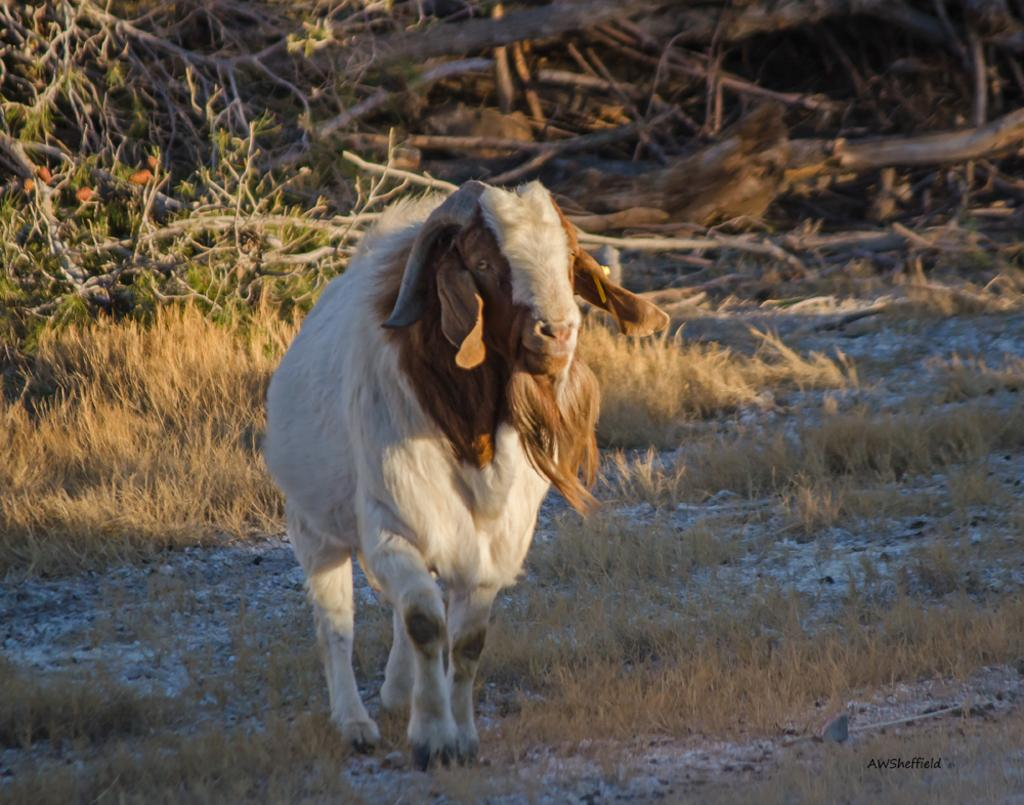What is the main subject in the middle of the image? There is an animal in the middle of the image. What type of environment is depicted in the background? There is grass and fallen trees in the background of the image. How does the animal contribute to the pollution in the image? The image does not depict any pollution, and there is no indication that the animal is contributing to any pollution. 